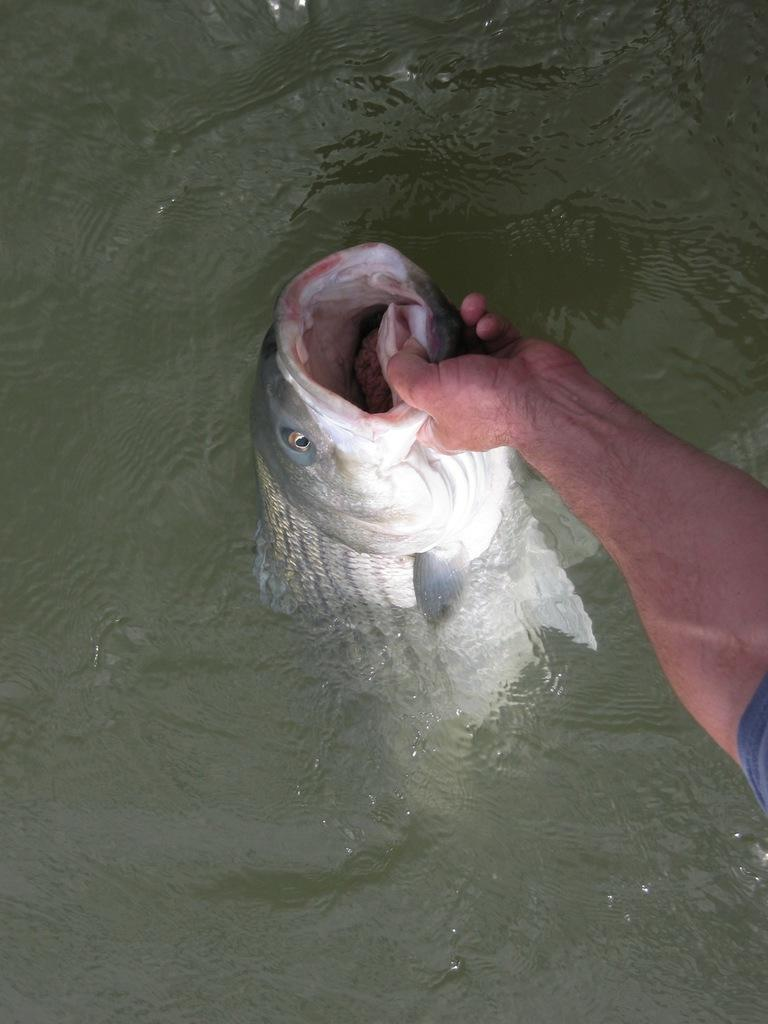What is the main subject of the image? There is a person in the image. What is the person holding in the image? The person is holding a fish. What can be seen at the bottom of the image? There is water visible at the bottom of the image. How many lizards can be seen crawling on the person's shoulder in the image? There are no lizards visible in the image; the person is holding a fish. What type of metal is the horn made of in the image? There is no horn present in the image. 